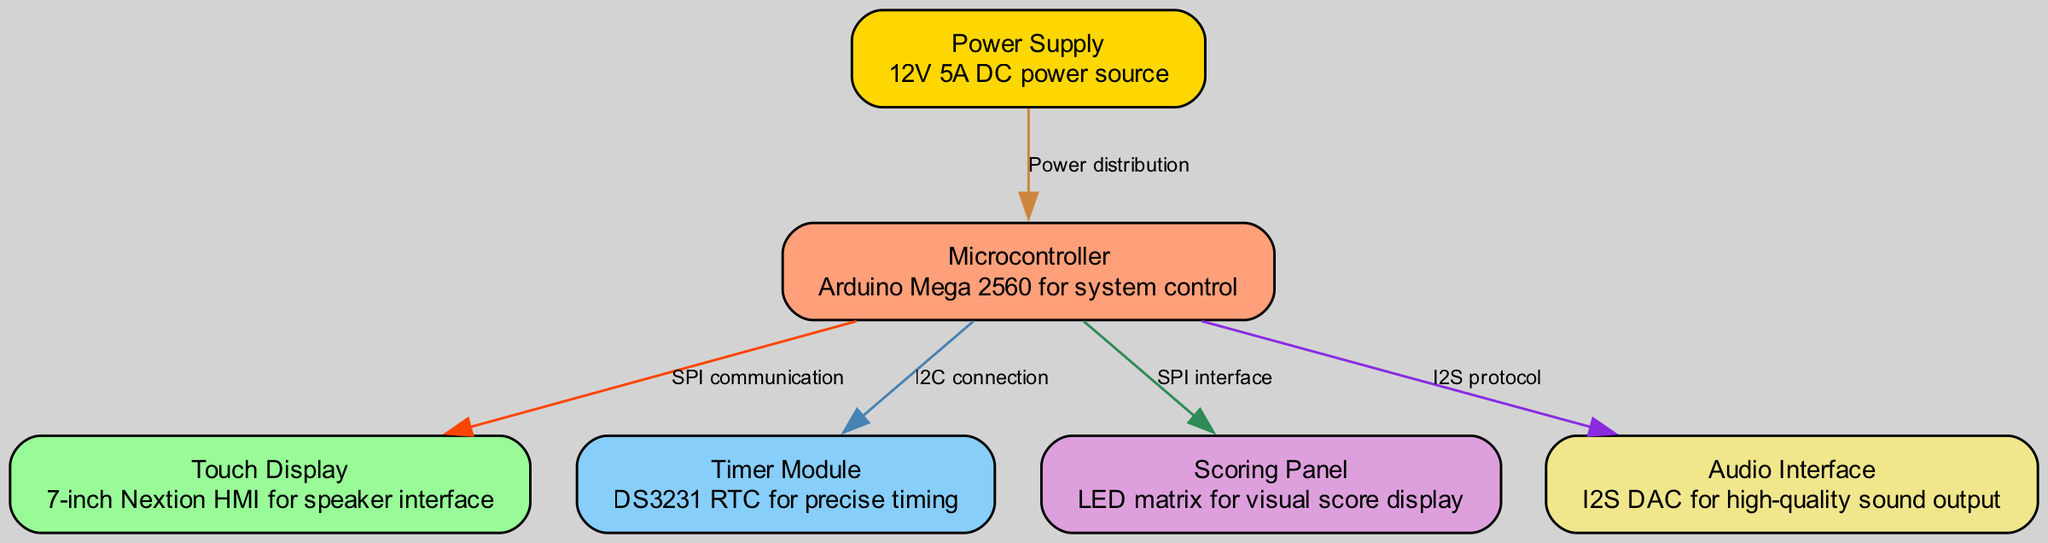What is the main microcontroller used in the podium? The diagram specifies that the main microcontroller is the Arduino Mega 2560. This can be found labeled under the "Microcontroller" node.
Answer: Arduino Mega 2560 How many nodes are depicted in the diagram? By counting the individual nodes listed in the data structure, we find there are six nodes present, which are the Microcontroller, Touch Display, Timer Module, Scoring Panel, Audio Interface, and Power Supply.
Answer: 6 What type of display is used in the podium? The diagram includes a "Touch Display" node, which is identified as a 7-inch Nextion HMI. This description provides the specific type of display technology utilized in the design.
Answer: 7-inch Nextion HMI What communication method connects the Microcontroller to the Timer Module? The edge labeled "I2C connection" indicates that the method of communication between the Microcontroller and the Timer Module is through I2C protocol. This can be confirmed by examining the edges connected to the respective nodes.
Answer: I2C connection Which module is responsible for precise timing in the system? The "Timer Module" node is described as having a DS3231 RTC, which is specifically designated for precise timing functions within the podium's system. This highlights its key role in maintaining accuracy.
Answer: Timer Module How is power distributed to the Microcontroller? The edge labeled "Power distribution" illustrates that the Power Supply node provides power to the Microcontroller, emphasizing the relationship between the power source and the control system.
Answer: Power distribution What type of output does the Audio Interface module provide? The Audio Interface node is described as an I2S DAC that is used for high-quality sound output, showing its function within the podium's audio system.
Answer: High-quality sound output What color is the scoring panel represented in the diagram? Referring to the node's assigned color, the Scoring Panel is shown as a plum color in the diagram. This detail refers to both its visual identity and representation within the schematic.
Answer: Plum How many types of communication methods are utilized in the diagram? The edges indicate four distinct types of communication methods: SPI communication, I2C connection, SPI interface, and I2S protocol. By analyzing the edges, we can count and confirm these distinct types.
Answer: 4 